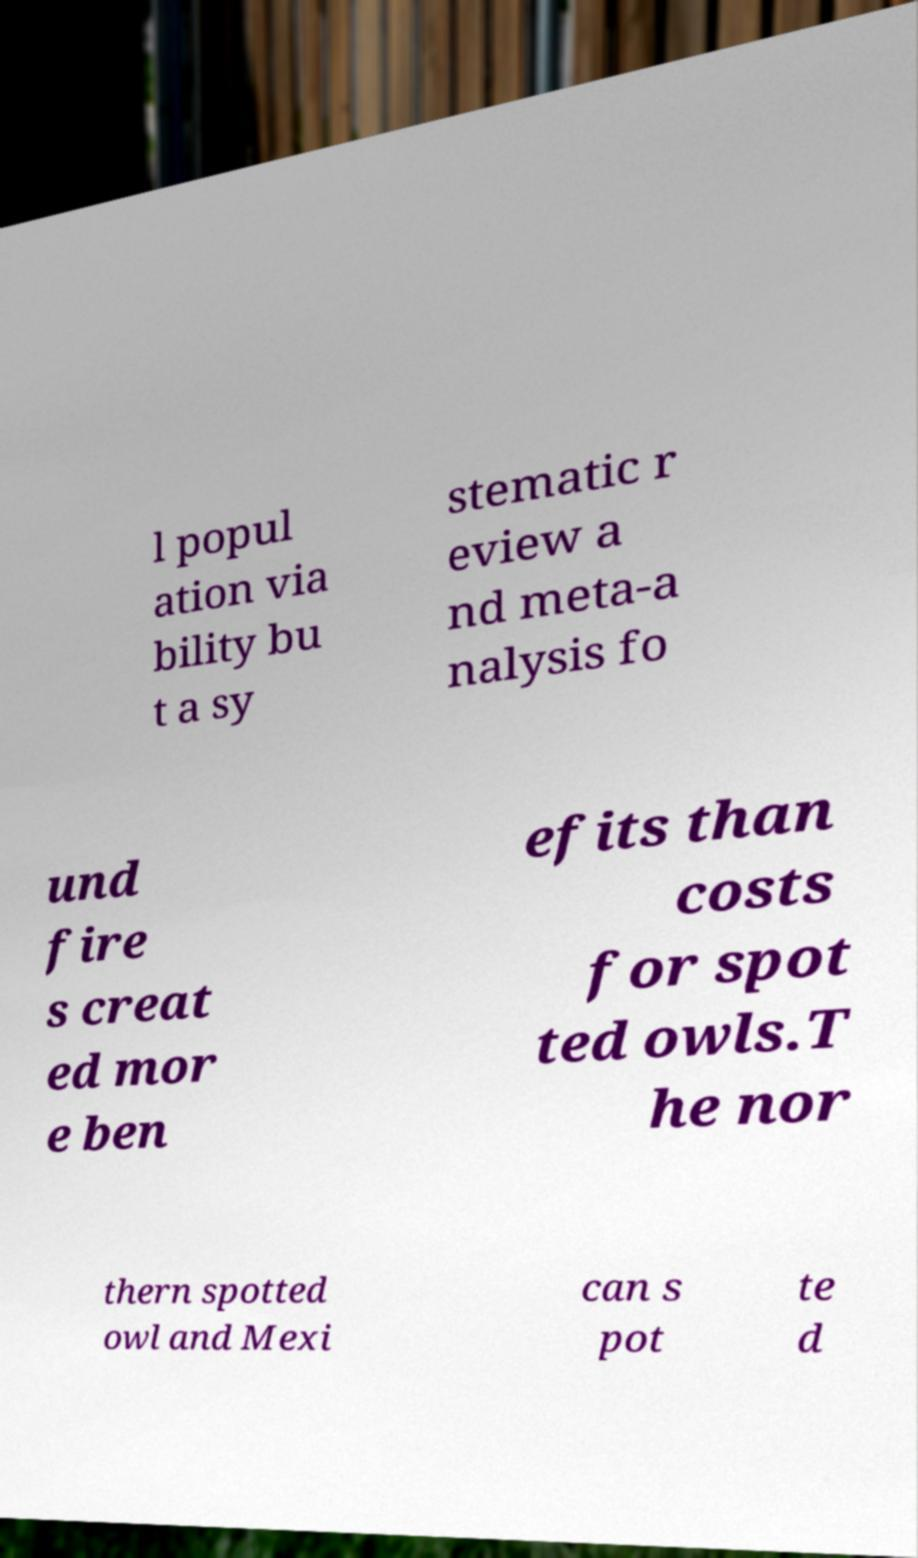I need the written content from this picture converted into text. Can you do that? l popul ation via bility bu t a sy stematic r eview a nd meta-a nalysis fo und fire s creat ed mor e ben efits than costs for spot ted owls.T he nor thern spotted owl and Mexi can s pot te d 